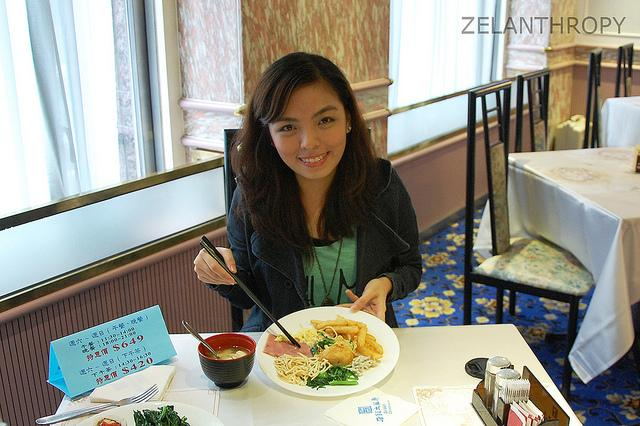Which city is most likely serving this restaurant? Please explain your reasoning. hong kong. Hong kong serves chinese food. 